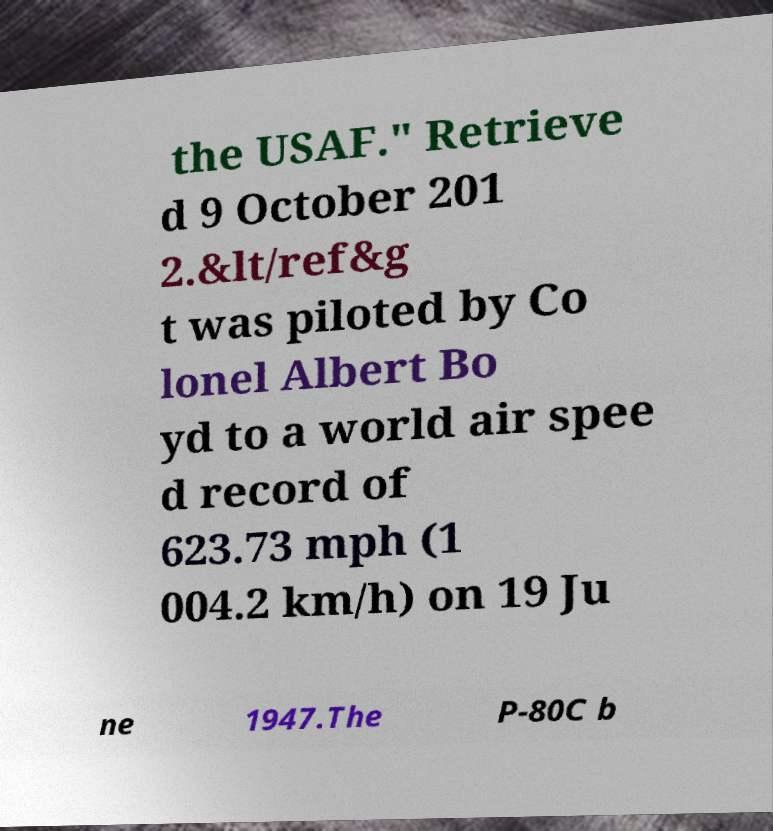For documentation purposes, I need the text within this image transcribed. Could you provide that? the USAF." Retrieve d 9 October 201 2.&lt/ref&g t was piloted by Co lonel Albert Bo yd to a world air spee d record of 623.73 mph (1 004.2 km/h) on 19 Ju ne 1947.The P-80C b 